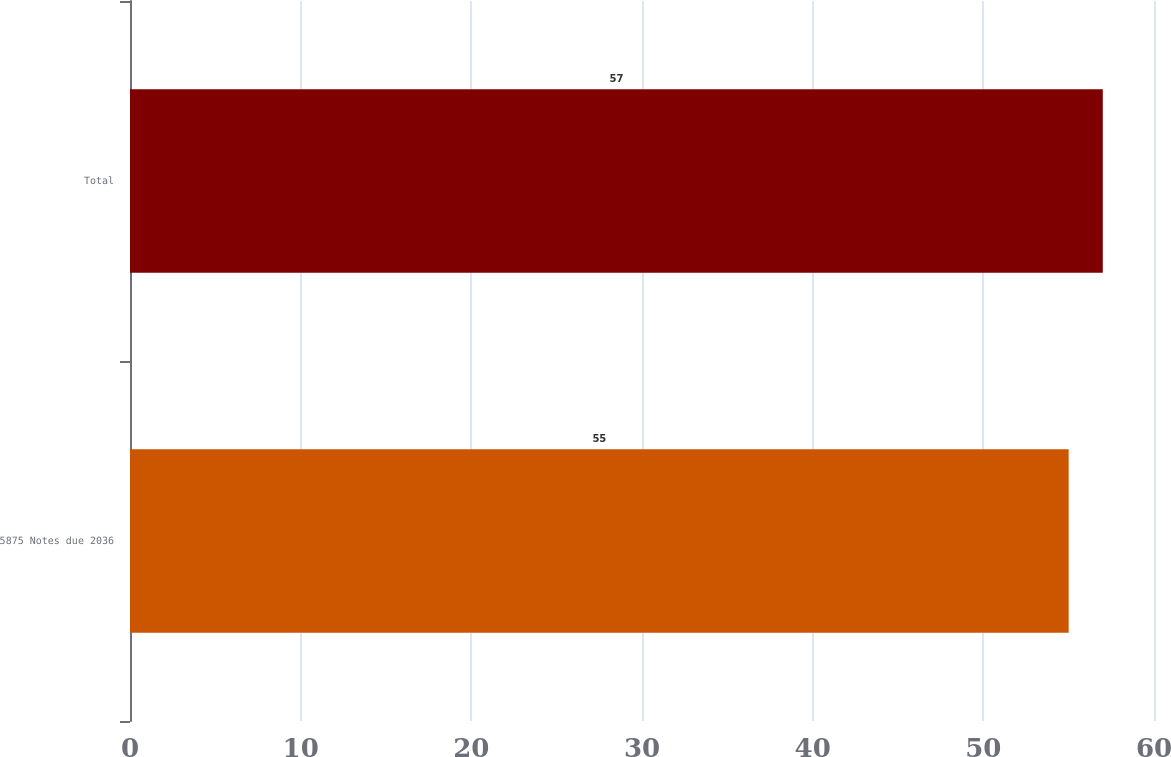<chart> <loc_0><loc_0><loc_500><loc_500><bar_chart><fcel>5875 Notes due 2036<fcel>Total<nl><fcel>55<fcel>57<nl></chart> 